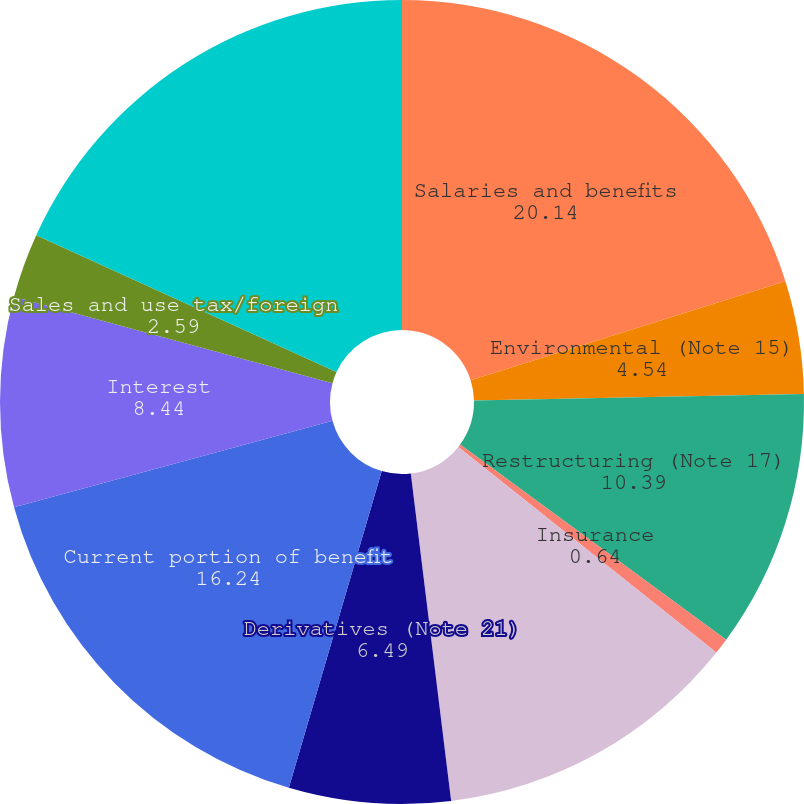Convert chart. <chart><loc_0><loc_0><loc_500><loc_500><pie_chart><fcel>Salaries and benefits<fcel>Environmental (Note 15)<fcel>Restructuring (Note 17)<fcel>Insurance<fcel>Asset retirement obligations<fcel>Derivatives (Note 21)<fcel>Current portion of benefit<fcel>Interest<fcel>Sales and use tax/foreign<fcel>Uncertain tax positions (Note<nl><fcel>20.14%<fcel>4.54%<fcel>10.39%<fcel>0.64%<fcel>12.34%<fcel>6.49%<fcel>16.24%<fcel>8.44%<fcel>2.59%<fcel>18.19%<nl></chart> 